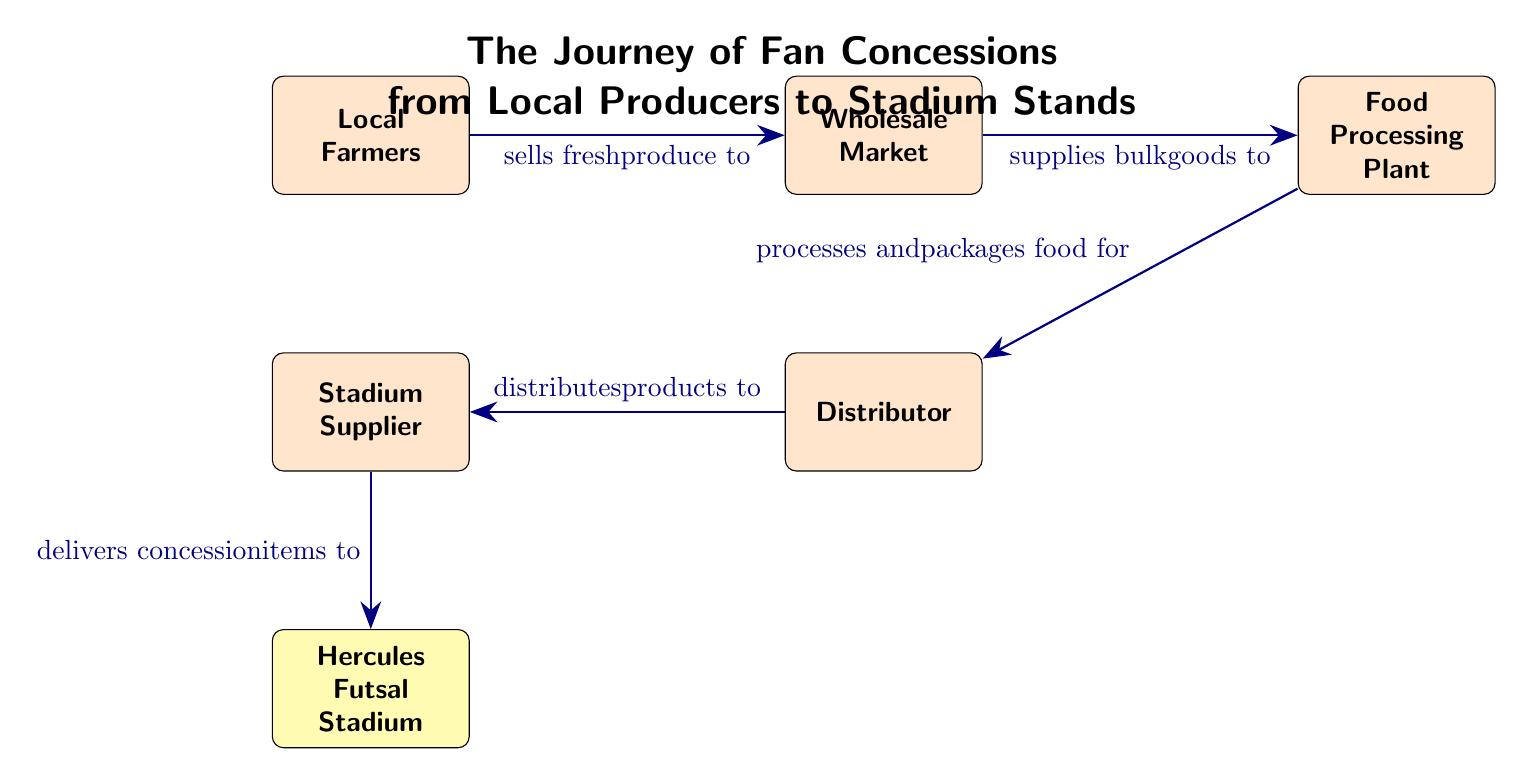What is the first node in the diagram? The first node is "Local Farmers," which represents the starting point of the food chain where fresh produce is sourced.
Answer: Local Farmers How many nodes are there in total? There are a total of six nodes in the diagram: Local Farmers, Wholesale Market, Food Processing Plant, Distributor, Stadium Supplier, and Hercules Futsal Stadium.
Answer: 6 What is the relationship between the Wholesale Market and Food Processing Plant? The Wholesale Market supplies bulk goods to the Food Processing Plant, indicating a direct link in the food chain where goods are passed from one entity to another.
Answer: supplies bulk goods to Who distributes products to the Stadium Supplier? The Distributor is responsible for distributing products to the Stadium Supplier, which is a key part of the food supply chain leading to the stadium.
Answer: Distributor Which node delivers concession items to Hercules Futsal Stadium? The Stadium Supplier delivers concession items to Hercules Futsal Stadium, confirming that the supplier is the final step before items reach the fans.
Answer: Stadium Supplier What process occurs at the Food Processing Plant? The Food Processing Plant processes and packages food for the Distributor, indicating its role in preparing the food for further distribution.
Answer: processes and packages food for Which node is the final destination in the food chain? The final destination in the food chain is Hercules Futsal Stadium, which is where the concession items ultimately end up for fans to enjoy during events.
Answer: Hercules Futsal Stadium How many connections (edges) are shown in the diagram? There are five connections (edges) depicted in the diagram, illustrating the flow of products from one node to the next.
Answer: 5 